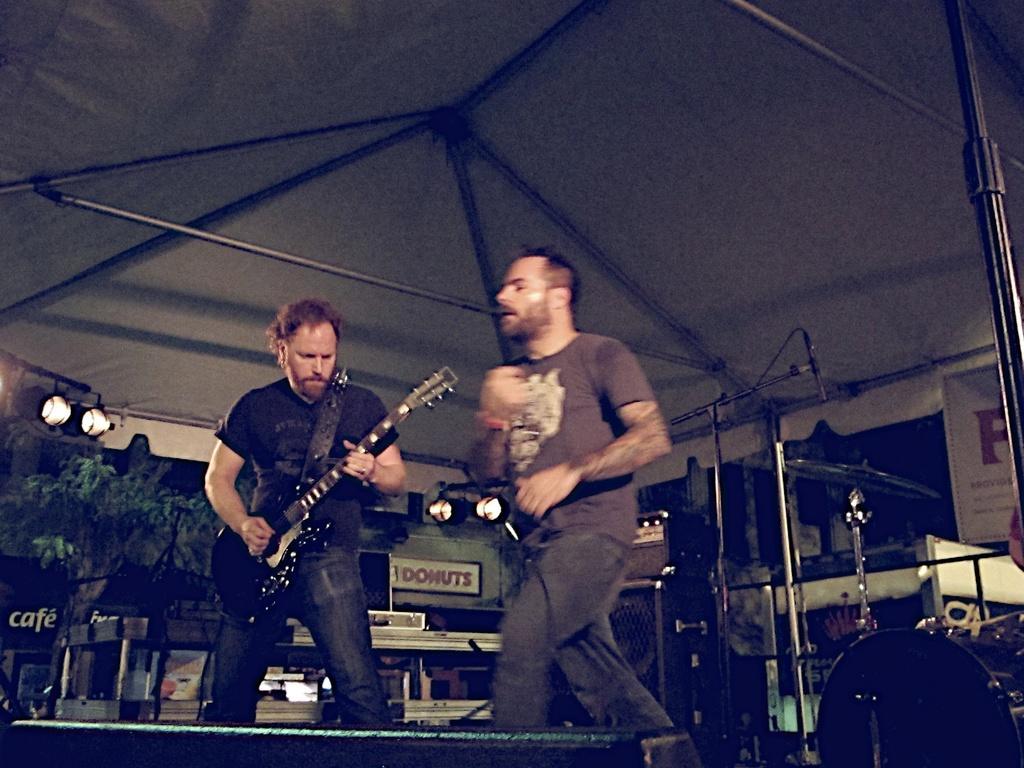Please provide a concise description of this image. There are two persons in the image. One person is standing and playing guitar. The other person I think he is dancing. This looks like a tent. At background I can see a speaker and some object placed on it. At the right corner of the image I can see a drum and hi-hat instruments. This is a tree and this looks like a restaurant with a name board. 